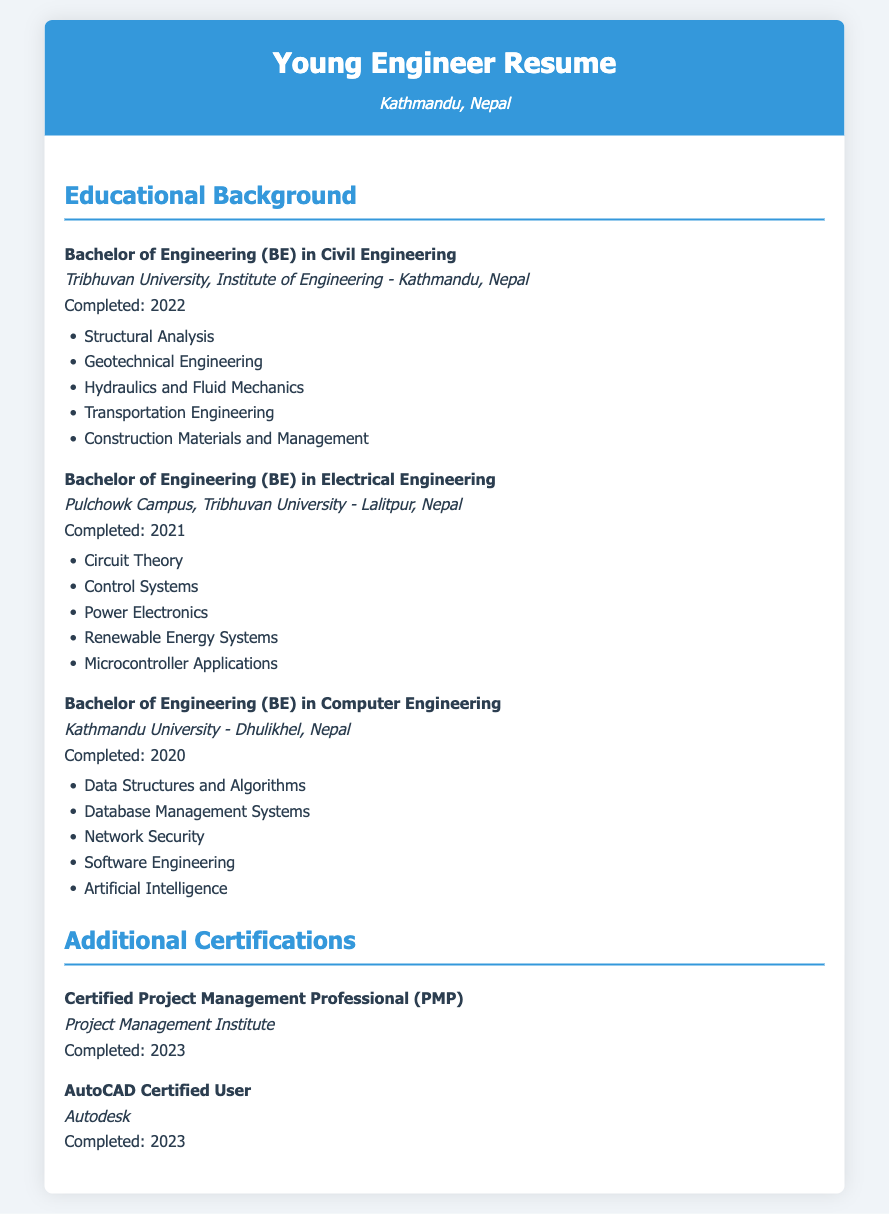What is the highest degree obtained? The highest degree listed in the document is the Bachelor of Engineering in Civil Engineering, completed in 2022.
Answer: Bachelor of Engineering (BE) in Civil Engineering What university did the Civil Engineering degree come from? The document states that the Civil Engineering degree was obtained from Tribhuvan University.
Answer: Tribhuvan University What year was the Electrical Engineering degree completed? The document specifies that the Electrical Engineering degree was completed in the year 2021.
Answer: 2021 How many courses are listed under the Computer Engineering degree? The document lists five specific courses that were part of the Computer Engineering degree.
Answer: 5 What certification was completed in 2023? The document indicates two certifications that were completed in 2023: Project Management Professional (PMP) and AutoCAD Certified User.
Answer: Project Management Professional (PMP), AutoCAD Certified User Which campus offered the Electrical Engineering program? The Electrical Engineering program was offered at Pulchowk Campus of Tribhuvan University, as mentioned in the document.
Answer: Pulchowk Campus What is one of the key subjects studied in the Computer Engineering degree? The document highlights several key subjects, including Data Structures and Algorithms as part of the Computer Engineering curriculum.
Answer: Data Structures and Algorithms Which engineering degree was completed last? The document lists the completion dates, indicating that the Civil Engineering degree was completed last in 2022.
Answer: Civil Engineering What is the focus of the course "Renewable Energy Systems"? The course focuses on alternative energy technologies as specified in the Electrical Engineering section of the document.
Answer: Alternative energy technologies 